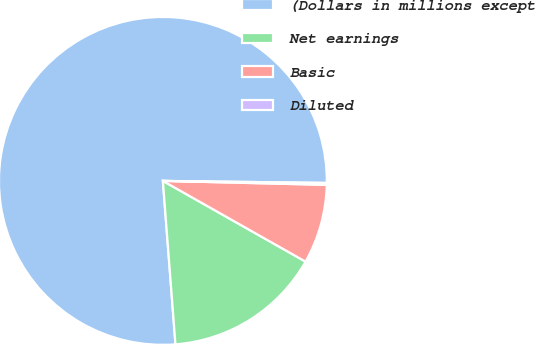Convert chart to OTSL. <chart><loc_0><loc_0><loc_500><loc_500><pie_chart><fcel>(Dollars in millions except<fcel>Net earnings<fcel>Basic<fcel>Diluted<nl><fcel>76.42%<fcel>15.58%<fcel>7.81%<fcel>0.19%<nl></chart> 